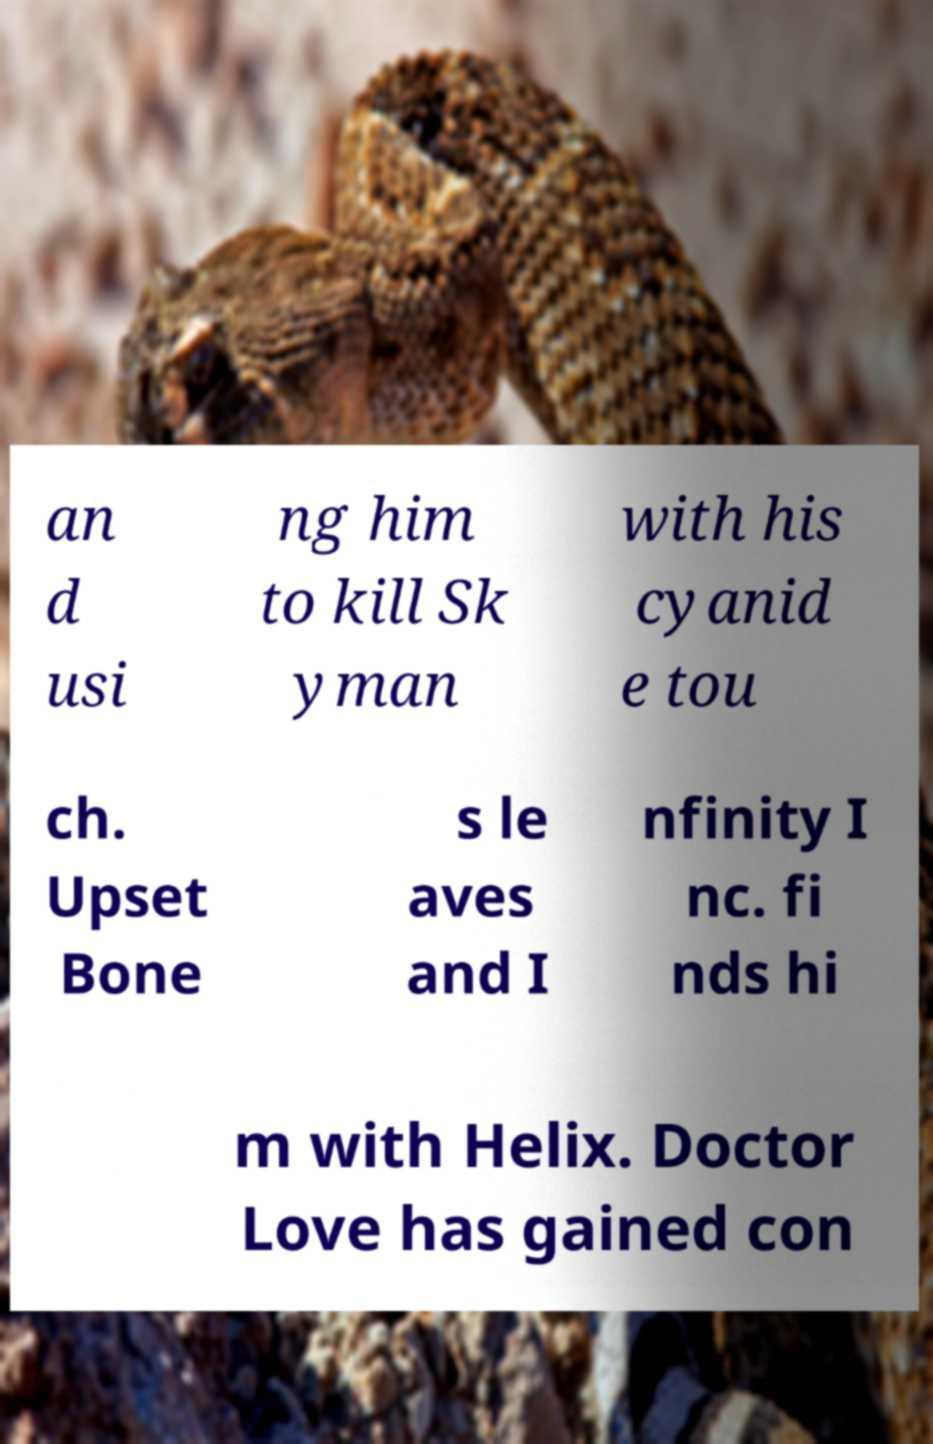For documentation purposes, I need the text within this image transcribed. Could you provide that? an d usi ng him to kill Sk yman with his cyanid e tou ch. Upset Bone s le aves and I nfinity I nc. fi nds hi m with Helix. Doctor Love has gained con 